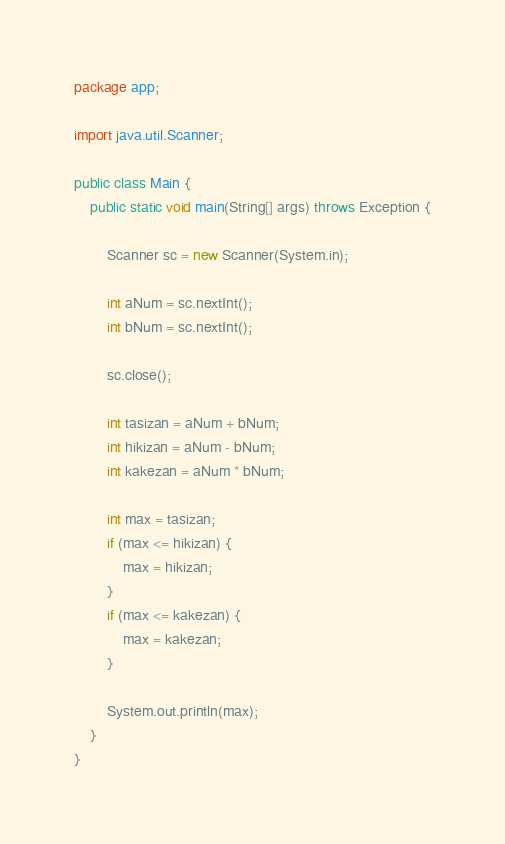<code> <loc_0><loc_0><loc_500><loc_500><_Java_>package app;

import java.util.Scanner;

public class Main {
    public static void main(String[] args) throws Exception {

        Scanner sc = new Scanner(System.in);

        int aNum = sc.nextInt();
        int bNum = sc.nextInt();

        sc.close();

        int tasizan = aNum + bNum;
        int hikizan = aNum - bNum;
        int kakezan = aNum * bNum;

        int max = tasizan;
        if (max <= hikizan) {
            max = hikizan;
        }
        if (max <= kakezan) {
            max = kakezan;
        }

        System.out.println(max);
    }
}</code> 